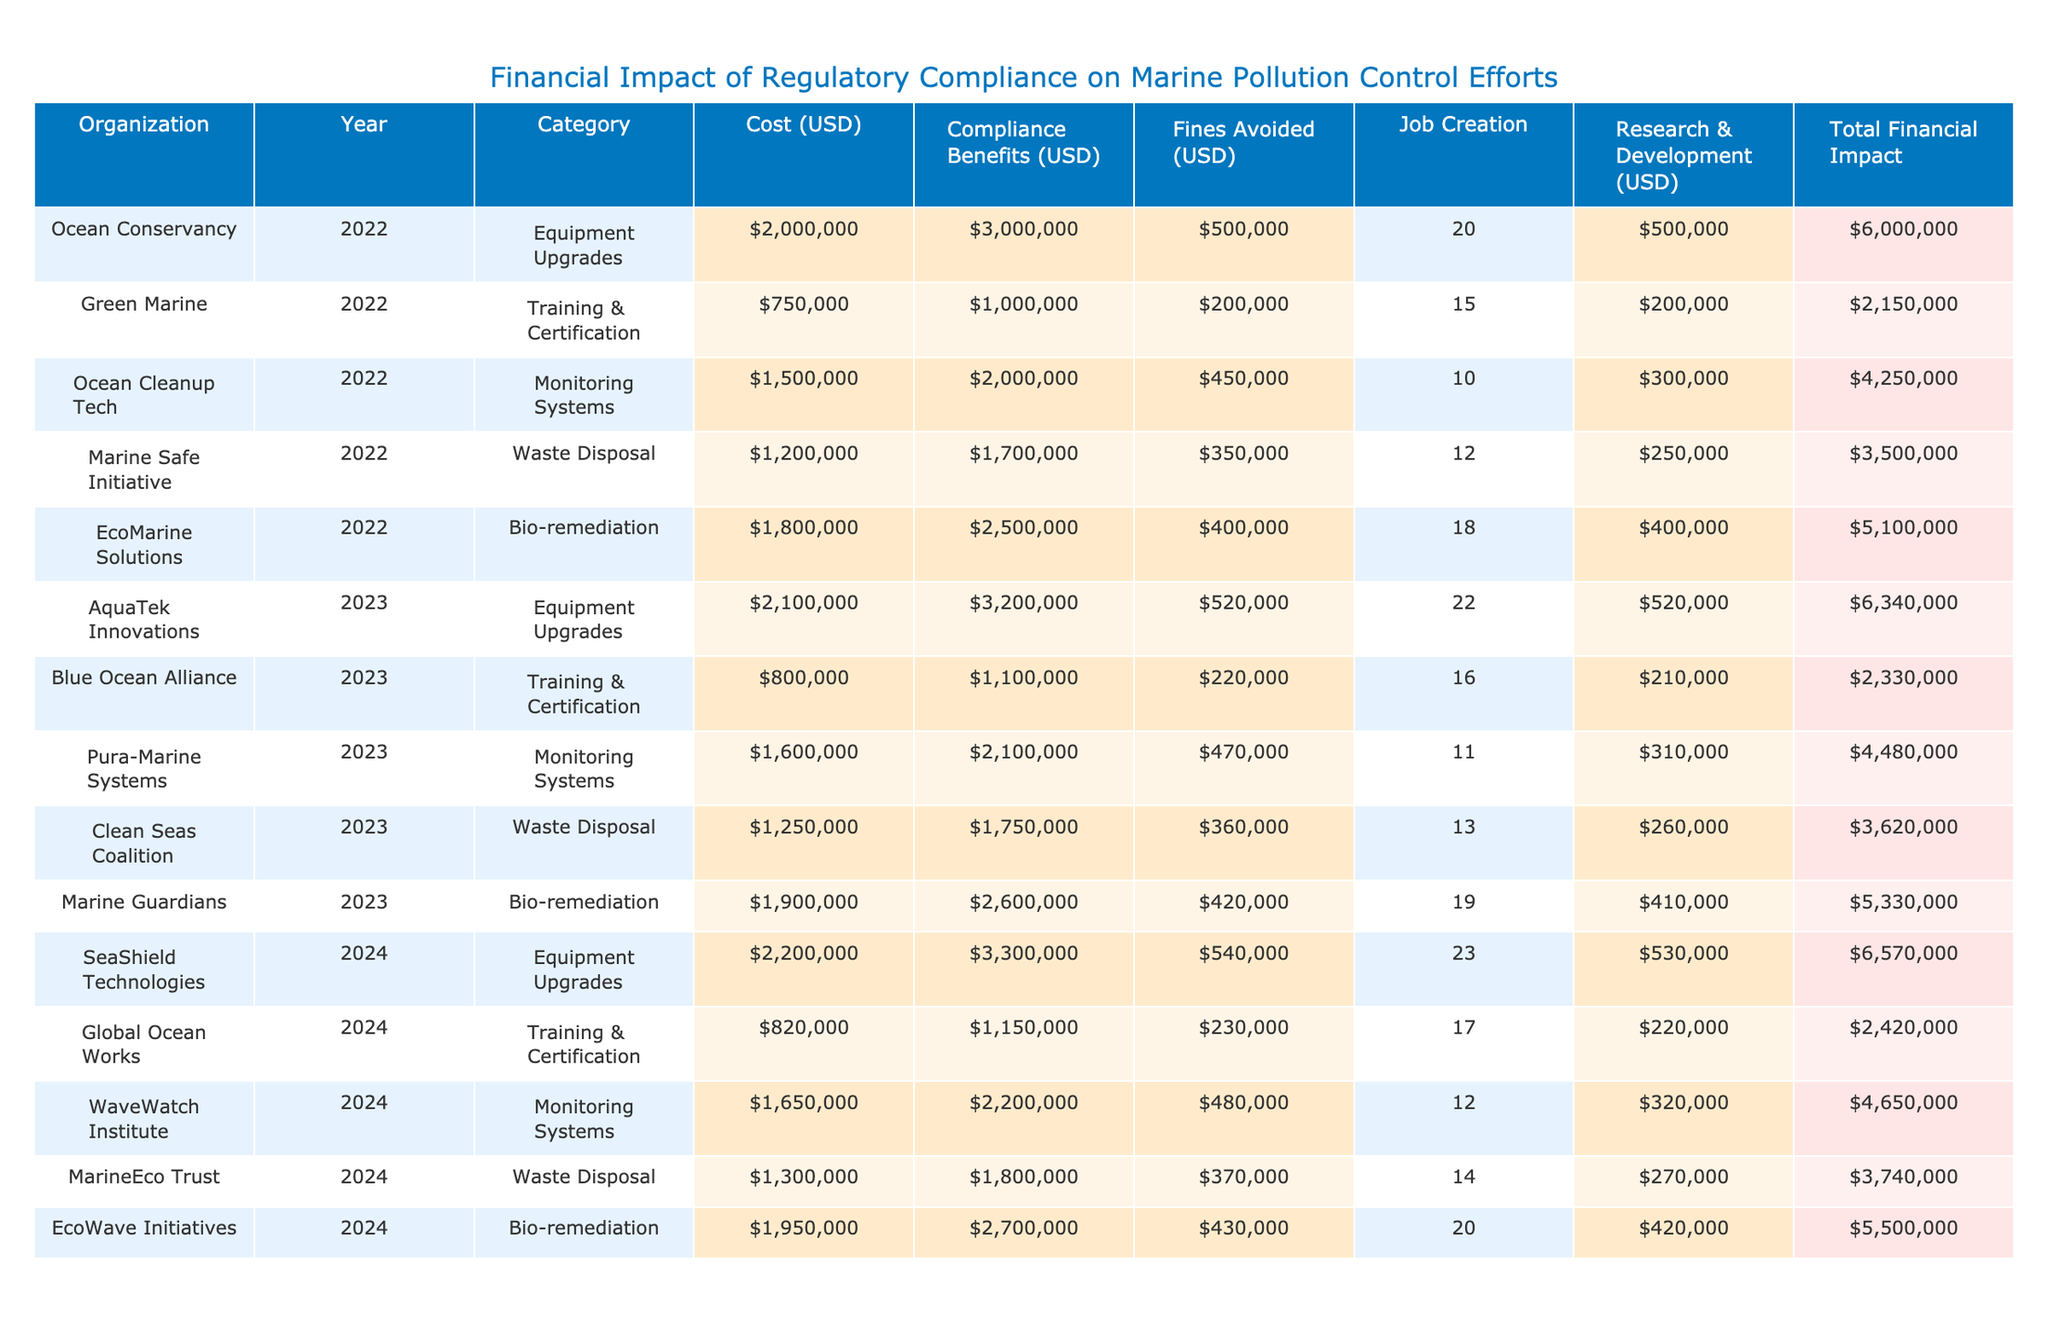What is the total financial impact for EcoMarine Solutions in 2022? The total financial impact is calculated by adding the cost, compliance benefits, fines avoided, and research & development expenses. For EcoMarine Solutions: Cost (1,800,000) + Compliance Benefits (2,500,000) + Fines Avoided (400,000) + Research & Development (400,000) = 5,100,000.
Answer: 5,100,000 Which organization achieved the highest job creation in 2024? By looking at the job creation column for 2024, EcoWave Initiatives has the highest number with 20 jobs created, compared to other organizations.
Answer: EcoWave Initiatives Adding the compliance benefits for AquaTek Innovations and Blue Ocean Alliance, what is the total? The compliance benefits for AquaTek Innovations in 2023 are 3,200,000 and for Blue Ocean Alliance in 2023 are 1,100,000. Adding these gives: 3,200,000 + 1,100,000 = 4,300,000.
Answer: 4,300,000 Did Marine Safe Initiative avoid more fines than Ocean Cleanup Tech in 2022? Marine Safe Initiative avoided fines of 350,000, while Ocean Cleanup Tech avoided fines of 450,000. Therefore, Marine Safe Initiative avoided fewer fines.
Answer: No What is the average cost of waste disposal efforts across all years? The total cost for waste disposal is calculated by summing the costs for the years 2022 (1,200,000), 2023 (1,250,000), and 2024 (1,300,000): 1,200,000 + 1,250,000 + 1,300,000 = 3,750,000. The average is then 3,750,000 / 3 = 1,250,000.
Answer: 1,250,000 In 2023, which organization reported the lowest fines avoided? Reviewing the fines avoided for 2023, both Pura-Marine Systems and Clean Seas Coalition avoided 360,000 and 360,000 respectively, while others avoided higher amounts. This suggests a tie for the lowest.
Answer: Pura-Marine Systems and Clean Seas Coalition What is the total cost of equipment upgrades across all years? The costs for equipment upgrades are: 2,000,000 (2022) + 2,100,000 (2023) + 2,200,000 (2024) = 6,300,000.
Answer: 6,300,000 Is the compliance benefit for any organization higher than 3,000,000 in the data provided? Checking through the compliance benefits, the highest value listed is 3,200,000 for AquaTek Innovations, which is indeed higher than 3,000,000.
Answer: Yes What is the difference in total financial impact between Green Marine in 2022 and Marine Guardians in 2023? First, calculate the total financial impact for Green Marine in 2022: 750,000 + 1,000,000 + 200,000 + 200,000 = 2,150,000. For Marine Guardians in 2023: 1,900,000 + 2,600,000 + 420,000 + 410,000 = 5,370,000. The difference is 5,370,000 - 2,150,000 = 3,220,000.
Answer: 3,220,000 